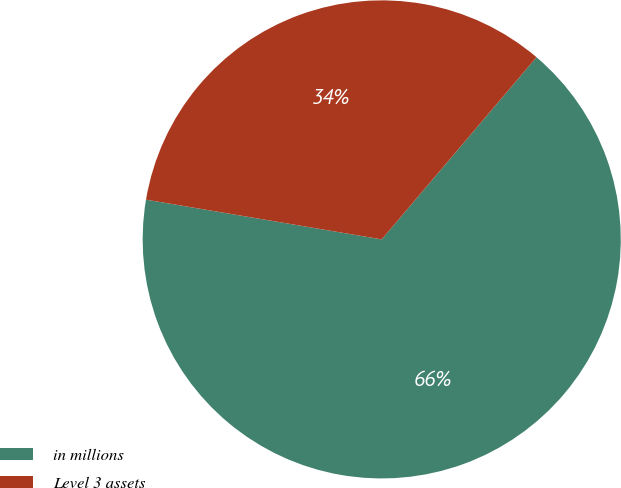<chart> <loc_0><loc_0><loc_500><loc_500><pie_chart><fcel>in millions<fcel>Level 3 assets<nl><fcel>66.45%<fcel>33.55%<nl></chart> 